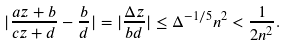<formula> <loc_0><loc_0><loc_500><loc_500>| \frac { a z + b } { c z + d } - \frac { b } { d } | = | \frac { \Delta z } { b d } | \leq \Delta ^ { - 1 / 5 } n ^ { 2 } < \frac { 1 } { 2 n ^ { 2 } } .</formula> 